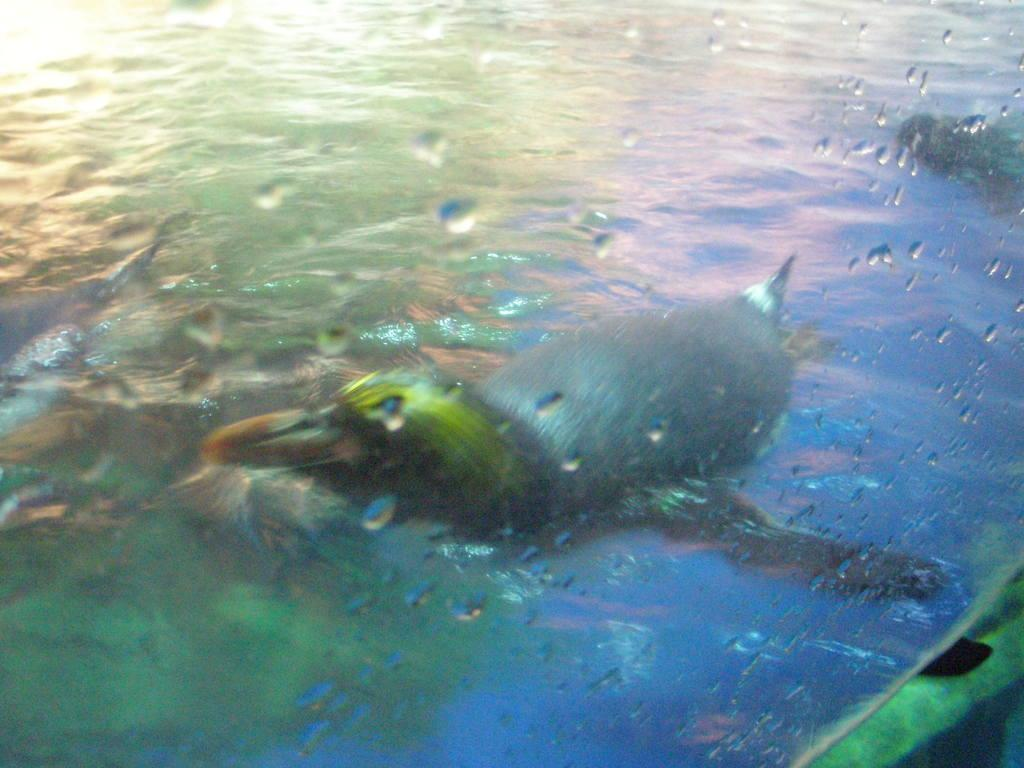What type of animals can be seen in the image? Birds can be seen in the image. Where are the birds situated in the image? The birds are in the water. What type of honey can be seen dripping from the ticket in the image? There is no honey or ticket present in the image; it features birds in the water. 